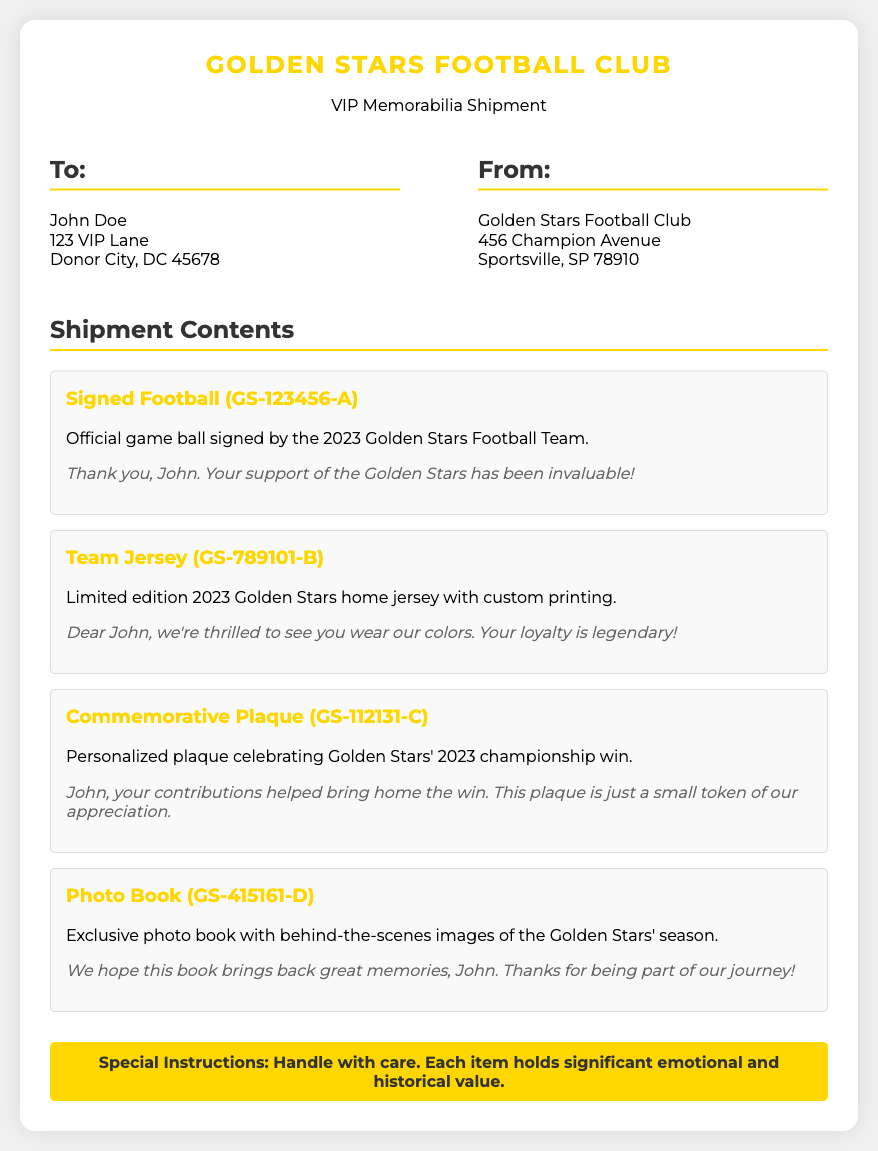What is the name of the recipient? The name of the recipient is clearly stated in the "To:" section of the document.
Answer: John Doe What is the address of the Golden Stars Football Club? The "From:" section provides the address of the Golden Stars Football Club.
Answer: 456 Champion Avenue, Sportsville, SP 78910 How many items are listed in the shipment contents? The total number of items can be counted in the "Shipment Contents" section of the document.
Answer: 4 What is the unique ID for the signed football? Each item has its own unique ID provided in parentheses next to the item name.
Answer: GS-123456-A What is the special instruction regarding the items? The "Special Instructions" section indicates how to handle the shipment.
Answer: Handle with care What is the greeting for the team jersey? Each item has a personalized message directed to the recipient included below its description.
Answer: Dear John, we're thrilled to see you wear our colors. Your loyalty is legendary! What type of item is the GS-112131-C? The unique ID allows you to identify the type of item associated with it in the shipment.
Answer: Commemorative Plaque What is the significance of the commemorative plaque? The description of the commemorative plaque indicates its celebratory and appreciative value.
Answer: Celebrating Golden Stars' 2023 championship win 